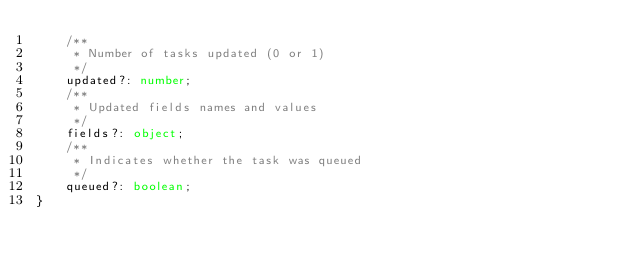<code> <loc_0><loc_0><loc_500><loc_500><_TypeScript_>    /**
     * Number of tasks updated (0 or 1)
     */
    updated?: number;
    /**
     * Updated fields names and values
     */
    fields?: object;
    /**
     * Indicates whether the task was queued
     */
    queued?: boolean;
}
</code> 